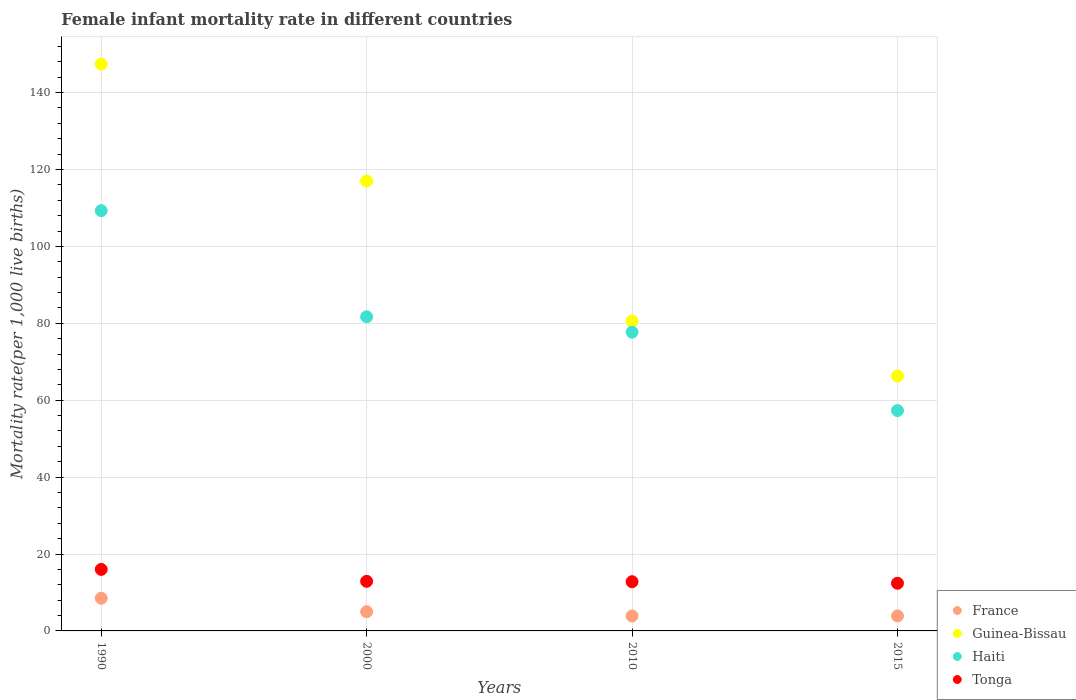How many different coloured dotlines are there?
Offer a terse response. 4. Across all years, what is the maximum female infant mortality rate in Haiti?
Keep it short and to the point. 109.3. Across all years, what is the minimum female infant mortality rate in Guinea-Bissau?
Your response must be concise. 66.3. In which year was the female infant mortality rate in Tonga maximum?
Ensure brevity in your answer.  1990. In which year was the female infant mortality rate in Guinea-Bissau minimum?
Provide a succinct answer. 2015. What is the total female infant mortality rate in Guinea-Bissau in the graph?
Your answer should be very brief. 411.3. What is the difference between the female infant mortality rate in Guinea-Bissau in 1990 and that in 2015?
Keep it short and to the point. 81.1. What is the difference between the female infant mortality rate in Tonga in 2015 and the female infant mortality rate in Haiti in 1990?
Make the answer very short. -96.9. What is the average female infant mortality rate in Tonga per year?
Ensure brevity in your answer.  13.53. In the year 2000, what is the difference between the female infant mortality rate in Guinea-Bissau and female infant mortality rate in France?
Offer a terse response. 112. What is the ratio of the female infant mortality rate in Guinea-Bissau in 2000 to that in 2015?
Give a very brief answer. 1.76. Is the female infant mortality rate in Haiti in 2010 less than that in 2015?
Your response must be concise. No. Is the difference between the female infant mortality rate in Guinea-Bissau in 1990 and 2010 greater than the difference between the female infant mortality rate in France in 1990 and 2010?
Your answer should be compact. Yes. What is the difference between the highest and the second highest female infant mortality rate in France?
Your answer should be very brief. 3.5. What is the difference between the highest and the lowest female infant mortality rate in Guinea-Bissau?
Ensure brevity in your answer.  81.1. In how many years, is the female infant mortality rate in Haiti greater than the average female infant mortality rate in Haiti taken over all years?
Give a very brief answer. 2. Is the sum of the female infant mortality rate in France in 2010 and 2015 greater than the maximum female infant mortality rate in Guinea-Bissau across all years?
Your response must be concise. No. Is it the case that in every year, the sum of the female infant mortality rate in Guinea-Bissau and female infant mortality rate in France  is greater than the sum of female infant mortality rate in Tonga and female infant mortality rate in Haiti?
Your answer should be very brief. Yes. Is it the case that in every year, the sum of the female infant mortality rate in Haiti and female infant mortality rate in Guinea-Bissau  is greater than the female infant mortality rate in Tonga?
Keep it short and to the point. Yes. How many dotlines are there?
Give a very brief answer. 4. How many years are there in the graph?
Provide a succinct answer. 4. Does the graph contain grids?
Your answer should be very brief. Yes. How many legend labels are there?
Offer a very short reply. 4. What is the title of the graph?
Your answer should be very brief. Female infant mortality rate in different countries. Does "Central African Republic" appear as one of the legend labels in the graph?
Provide a short and direct response. No. What is the label or title of the X-axis?
Provide a succinct answer. Years. What is the label or title of the Y-axis?
Ensure brevity in your answer.  Mortality rate(per 1,0 live births). What is the Mortality rate(per 1,000 live births) in Guinea-Bissau in 1990?
Your response must be concise. 147.4. What is the Mortality rate(per 1,000 live births) of Haiti in 1990?
Make the answer very short. 109.3. What is the Mortality rate(per 1,000 live births) in France in 2000?
Your answer should be very brief. 5. What is the Mortality rate(per 1,000 live births) of Guinea-Bissau in 2000?
Provide a short and direct response. 117. What is the Mortality rate(per 1,000 live births) in Haiti in 2000?
Provide a succinct answer. 81.7. What is the Mortality rate(per 1,000 live births) in Tonga in 2000?
Ensure brevity in your answer.  12.9. What is the Mortality rate(per 1,000 live births) of France in 2010?
Your response must be concise. 3.9. What is the Mortality rate(per 1,000 live births) in Guinea-Bissau in 2010?
Your response must be concise. 80.6. What is the Mortality rate(per 1,000 live births) in Haiti in 2010?
Offer a terse response. 77.7. What is the Mortality rate(per 1,000 live births) of Guinea-Bissau in 2015?
Provide a short and direct response. 66.3. What is the Mortality rate(per 1,000 live births) of Haiti in 2015?
Your response must be concise. 57.3. Across all years, what is the maximum Mortality rate(per 1,000 live births) of Guinea-Bissau?
Make the answer very short. 147.4. Across all years, what is the maximum Mortality rate(per 1,000 live births) in Haiti?
Offer a terse response. 109.3. Across all years, what is the minimum Mortality rate(per 1,000 live births) in Guinea-Bissau?
Offer a terse response. 66.3. Across all years, what is the minimum Mortality rate(per 1,000 live births) of Haiti?
Keep it short and to the point. 57.3. Across all years, what is the minimum Mortality rate(per 1,000 live births) of Tonga?
Your answer should be very brief. 12.4. What is the total Mortality rate(per 1,000 live births) in France in the graph?
Your answer should be very brief. 21.3. What is the total Mortality rate(per 1,000 live births) of Guinea-Bissau in the graph?
Ensure brevity in your answer.  411.3. What is the total Mortality rate(per 1,000 live births) in Haiti in the graph?
Your answer should be very brief. 326. What is the total Mortality rate(per 1,000 live births) of Tonga in the graph?
Your answer should be compact. 54.1. What is the difference between the Mortality rate(per 1,000 live births) of Guinea-Bissau in 1990 and that in 2000?
Offer a terse response. 30.4. What is the difference between the Mortality rate(per 1,000 live births) of Haiti in 1990 and that in 2000?
Ensure brevity in your answer.  27.6. What is the difference between the Mortality rate(per 1,000 live births) in Tonga in 1990 and that in 2000?
Make the answer very short. 3.1. What is the difference between the Mortality rate(per 1,000 live births) of Guinea-Bissau in 1990 and that in 2010?
Make the answer very short. 66.8. What is the difference between the Mortality rate(per 1,000 live births) in Haiti in 1990 and that in 2010?
Keep it short and to the point. 31.6. What is the difference between the Mortality rate(per 1,000 live births) in Tonga in 1990 and that in 2010?
Keep it short and to the point. 3.2. What is the difference between the Mortality rate(per 1,000 live births) in France in 1990 and that in 2015?
Your answer should be compact. 4.6. What is the difference between the Mortality rate(per 1,000 live births) of Guinea-Bissau in 1990 and that in 2015?
Offer a terse response. 81.1. What is the difference between the Mortality rate(per 1,000 live births) of Haiti in 1990 and that in 2015?
Provide a succinct answer. 52. What is the difference between the Mortality rate(per 1,000 live births) in Guinea-Bissau in 2000 and that in 2010?
Keep it short and to the point. 36.4. What is the difference between the Mortality rate(per 1,000 live births) in Tonga in 2000 and that in 2010?
Keep it short and to the point. 0.1. What is the difference between the Mortality rate(per 1,000 live births) in France in 2000 and that in 2015?
Make the answer very short. 1.1. What is the difference between the Mortality rate(per 1,000 live births) of Guinea-Bissau in 2000 and that in 2015?
Your response must be concise. 50.7. What is the difference between the Mortality rate(per 1,000 live births) in Haiti in 2000 and that in 2015?
Your answer should be very brief. 24.4. What is the difference between the Mortality rate(per 1,000 live births) in Guinea-Bissau in 2010 and that in 2015?
Provide a short and direct response. 14.3. What is the difference between the Mortality rate(per 1,000 live births) of Haiti in 2010 and that in 2015?
Your response must be concise. 20.4. What is the difference between the Mortality rate(per 1,000 live births) of France in 1990 and the Mortality rate(per 1,000 live births) of Guinea-Bissau in 2000?
Your response must be concise. -108.5. What is the difference between the Mortality rate(per 1,000 live births) of France in 1990 and the Mortality rate(per 1,000 live births) of Haiti in 2000?
Offer a terse response. -73.2. What is the difference between the Mortality rate(per 1,000 live births) of France in 1990 and the Mortality rate(per 1,000 live births) of Tonga in 2000?
Your response must be concise. -4.4. What is the difference between the Mortality rate(per 1,000 live births) in Guinea-Bissau in 1990 and the Mortality rate(per 1,000 live births) in Haiti in 2000?
Keep it short and to the point. 65.7. What is the difference between the Mortality rate(per 1,000 live births) in Guinea-Bissau in 1990 and the Mortality rate(per 1,000 live births) in Tonga in 2000?
Ensure brevity in your answer.  134.5. What is the difference between the Mortality rate(per 1,000 live births) in Haiti in 1990 and the Mortality rate(per 1,000 live births) in Tonga in 2000?
Your response must be concise. 96.4. What is the difference between the Mortality rate(per 1,000 live births) in France in 1990 and the Mortality rate(per 1,000 live births) in Guinea-Bissau in 2010?
Make the answer very short. -72.1. What is the difference between the Mortality rate(per 1,000 live births) of France in 1990 and the Mortality rate(per 1,000 live births) of Haiti in 2010?
Provide a short and direct response. -69.2. What is the difference between the Mortality rate(per 1,000 live births) in France in 1990 and the Mortality rate(per 1,000 live births) in Tonga in 2010?
Your answer should be very brief. -4.3. What is the difference between the Mortality rate(per 1,000 live births) of Guinea-Bissau in 1990 and the Mortality rate(per 1,000 live births) of Haiti in 2010?
Give a very brief answer. 69.7. What is the difference between the Mortality rate(per 1,000 live births) of Guinea-Bissau in 1990 and the Mortality rate(per 1,000 live births) of Tonga in 2010?
Your answer should be very brief. 134.6. What is the difference between the Mortality rate(per 1,000 live births) in Haiti in 1990 and the Mortality rate(per 1,000 live births) in Tonga in 2010?
Make the answer very short. 96.5. What is the difference between the Mortality rate(per 1,000 live births) of France in 1990 and the Mortality rate(per 1,000 live births) of Guinea-Bissau in 2015?
Ensure brevity in your answer.  -57.8. What is the difference between the Mortality rate(per 1,000 live births) in France in 1990 and the Mortality rate(per 1,000 live births) in Haiti in 2015?
Your response must be concise. -48.8. What is the difference between the Mortality rate(per 1,000 live births) in Guinea-Bissau in 1990 and the Mortality rate(per 1,000 live births) in Haiti in 2015?
Offer a very short reply. 90.1. What is the difference between the Mortality rate(per 1,000 live births) in Guinea-Bissau in 1990 and the Mortality rate(per 1,000 live births) in Tonga in 2015?
Your response must be concise. 135. What is the difference between the Mortality rate(per 1,000 live births) of Haiti in 1990 and the Mortality rate(per 1,000 live births) of Tonga in 2015?
Provide a succinct answer. 96.9. What is the difference between the Mortality rate(per 1,000 live births) in France in 2000 and the Mortality rate(per 1,000 live births) in Guinea-Bissau in 2010?
Provide a succinct answer. -75.6. What is the difference between the Mortality rate(per 1,000 live births) in France in 2000 and the Mortality rate(per 1,000 live births) in Haiti in 2010?
Offer a terse response. -72.7. What is the difference between the Mortality rate(per 1,000 live births) of Guinea-Bissau in 2000 and the Mortality rate(per 1,000 live births) of Haiti in 2010?
Your answer should be very brief. 39.3. What is the difference between the Mortality rate(per 1,000 live births) of Guinea-Bissau in 2000 and the Mortality rate(per 1,000 live births) of Tonga in 2010?
Offer a terse response. 104.2. What is the difference between the Mortality rate(per 1,000 live births) in Haiti in 2000 and the Mortality rate(per 1,000 live births) in Tonga in 2010?
Keep it short and to the point. 68.9. What is the difference between the Mortality rate(per 1,000 live births) in France in 2000 and the Mortality rate(per 1,000 live births) in Guinea-Bissau in 2015?
Offer a very short reply. -61.3. What is the difference between the Mortality rate(per 1,000 live births) in France in 2000 and the Mortality rate(per 1,000 live births) in Haiti in 2015?
Make the answer very short. -52.3. What is the difference between the Mortality rate(per 1,000 live births) of Guinea-Bissau in 2000 and the Mortality rate(per 1,000 live births) of Haiti in 2015?
Your response must be concise. 59.7. What is the difference between the Mortality rate(per 1,000 live births) in Guinea-Bissau in 2000 and the Mortality rate(per 1,000 live births) in Tonga in 2015?
Give a very brief answer. 104.6. What is the difference between the Mortality rate(per 1,000 live births) in Haiti in 2000 and the Mortality rate(per 1,000 live births) in Tonga in 2015?
Provide a short and direct response. 69.3. What is the difference between the Mortality rate(per 1,000 live births) of France in 2010 and the Mortality rate(per 1,000 live births) of Guinea-Bissau in 2015?
Ensure brevity in your answer.  -62.4. What is the difference between the Mortality rate(per 1,000 live births) of France in 2010 and the Mortality rate(per 1,000 live births) of Haiti in 2015?
Give a very brief answer. -53.4. What is the difference between the Mortality rate(per 1,000 live births) of Guinea-Bissau in 2010 and the Mortality rate(per 1,000 live births) of Haiti in 2015?
Your response must be concise. 23.3. What is the difference between the Mortality rate(per 1,000 live births) in Guinea-Bissau in 2010 and the Mortality rate(per 1,000 live births) in Tonga in 2015?
Offer a very short reply. 68.2. What is the difference between the Mortality rate(per 1,000 live births) of Haiti in 2010 and the Mortality rate(per 1,000 live births) of Tonga in 2015?
Make the answer very short. 65.3. What is the average Mortality rate(per 1,000 live births) of France per year?
Your answer should be very brief. 5.33. What is the average Mortality rate(per 1,000 live births) in Guinea-Bissau per year?
Provide a succinct answer. 102.83. What is the average Mortality rate(per 1,000 live births) in Haiti per year?
Your answer should be compact. 81.5. What is the average Mortality rate(per 1,000 live births) in Tonga per year?
Your answer should be very brief. 13.53. In the year 1990, what is the difference between the Mortality rate(per 1,000 live births) in France and Mortality rate(per 1,000 live births) in Guinea-Bissau?
Your answer should be compact. -138.9. In the year 1990, what is the difference between the Mortality rate(per 1,000 live births) in France and Mortality rate(per 1,000 live births) in Haiti?
Offer a very short reply. -100.8. In the year 1990, what is the difference between the Mortality rate(per 1,000 live births) in Guinea-Bissau and Mortality rate(per 1,000 live births) in Haiti?
Provide a short and direct response. 38.1. In the year 1990, what is the difference between the Mortality rate(per 1,000 live births) of Guinea-Bissau and Mortality rate(per 1,000 live births) of Tonga?
Keep it short and to the point. 131.4. In the year 1990, what is the difference between the Mortality rate(per 1,000 live births) of Haiti and Mortality rate(per 1,000 live births) of Tonga?
Ensure brevity in your answer.  93.3. In the year 2000, what is the difference between the Mortality rate(per 1,000 live births) in France and Mortality rate(per 1,000 live births) in Guinea-Bissau?
Provide a short and direct response. -112. In the year 2000, what is the difference between the Mortality rate(per 1,000 live births) in France and Mortality rate(per 1,000 live births) in Haiti?
Keep it short and to the point. -76.7. In the year 2000, what is the difference between the Mortality rate(per 1,000 live births) in France and Mortality rate(per 1,000 live births) in Tonga?
Give a very brief answer. -7.9. In the year 2000, what is the difference between the Mortality rate(per 1,000 live births) of Guinea-Bissau and Mortality rate(per 1,000 live births) of Haiti?
Provide a short and direct response. 35.3. In the year 2000, what is the difference between the Mortality rate(per 1,000 live births) of Guinea-Bissau and Mortality rate(per 1,000 live births) of Tonga?
Provide a short and direct response. 104.1. In the year 2000, what is the difference between the Mortality rate(per 1,000 live births) in Haiti and Mortality rate(per 1,000 live births) in Tonga?
Offer a very short reply. 68.8. In the year 2010, what is the difference between the Mortality rate(per 1,000 live births) of France and Mortality rate(per 1,000 live births) of Guinea-Bissau?
Your answer should be very brief. -76.7. In the year 2010, what is the difference between the Mortality rate(per 1,000 live births) in France and Mortality rate(per 1,000 live births) in Haiti?
Your answer should be very brief. -73.8. In the year 2010, what is the difference between the Mortality rate(per 1,000 live births) of Guinea-Bissau and Mortality rate(per 1,000 live births) of Tonga?
Your answer should be compact. 67.8. In the year 2010, what is the difference between the Mortality rate(per 1,000 live births) of Haiti and Mortality rate(per 1,000 live births) of Tonga?
Offer a very short reply. 64.9. In the year 2015, what is the difference between the Mortality rate(per 1,000 live births) in France and Mortality rate(per 1,000 live births) in Guinea-Bissau?
Offer a very short reply. -62.4. In the year 2015, what is the difference between the Mortality rate(per 1,000 live births) of France and Mortality rate(per 1,000 live births) of Haiti?
Offer a terse response. -53.4. In the year 2015, what is the difference between the Mortality rate(per 1,000 live births) of Guinea-Bissau and Mortality rate(per 1,000 live births) of Tonga?
Ensure brevity in your answer.  53.9. In the year 2015, what is the difference between the Mortality rate(per 1,000 live births) of Haiti and Mortality rate(per 1,000 live births) of Tonga?
Your response must be concise. 44.9. What is the ratio of the Mortality rate(per 1,000 live births) in France in 1990 to that in 2000?
Your answer should be very brief. 1.7. What is the ratio of the Mortality rate(per 1,000 live births) in Guinea-Bissau in 1990 to that in 2000?
Give a very brief answer. 1.26. What is the ratio of the Mortality rate(per 1,000 live births) in Haiti in 1990 to that in 2000?
Provide a succinct answer. 1.34. What is the ratio of the Mortality rate(per 1,000 live births) of Tonga in 1990 to that in 2000?
Your answer should be compact. 1.24. What is the ratio of the Mortality rate(per 1,000 live births) of France in 1990 to that in 2010?
Your answer should be compact. 2.18. What is the ratio of the Mortality rate(per 1,000 live births) in Guinea-Bissau in 1990 to that in 2010?
Give a very brief answer. 1.83. What is the ratio of the Mortality rate(per 1,000 live births) of Haiti in 1990 to that in 2010?
Keep it short and to the point. 1.41. What is the ratio of the Mortality rate(per 1,000 live births) of France in 1990 to that in 2015?
Keep it short and to the point. 2.18. What is the ratio of the Mortality rate(per 1,000 live births) in Guinea-Bissau in 1990 to that in 2015?
Provide a succinct answer. 2.22. What is the ratio of the Mortality rate(per 1,000 live births) of Haiti in 1990 to that in 2015?
Your response must be concise. 1.91. What is the ratio of the Mortality rate(per 1,000 live births) in Tonga in 1990 to that in 2015?
Provide a succinct answer. 1.29. What is the ratio of the Mortality rate(per 1,000 live births) in France in 2000 to that in 2010?
Your answer should be very brief. 1.28. What is the ratio of the Mortality rate(per 1,000 live births) of Guinea-Bissau in 2000 to that in 2010?
Provide a short and direct response. 1.45. What is the ratio of the Mortality rate(per 1,000 live births) of Haiti in 2000 to that in 2010?
Your answer should be compact. 1.05. What is the ratio of the Mortality rate(per 1,000 live births) in Tonga in 2000 to that in 2010?
Give a very brief answer. 1.01. What is the ratio of the Mortality rate(per 1,000 live births) of France in 2000 to that in 2015?
Keep it short and to the point. 1.28. What is the ratio of the Mortality rate(per 1,000 live births) of Guinea-Bissau in 2000 to that in 2015?
Ensure brevity in your answer.  1.76. What is the ratio of the Mortality rate(per 1,000 live births) in Haiti in 2000 to that in 2015?
Your answer should be compact. 1.43. What is the ratio of the Mortality rate(per 1,000 live births) of Tonga in 2000 to that in 2015?
Keep it short and to the point. 1.04. What is the ratio of the Mortality rate(per 1,000 live births) in France in 2010 to that in 2015?
Give a very brief answer. 1. What is the ratio of the Mortality rate(per 1,000 live births) in Guinea-Bissau in 2010 to that in 2015?
Provide a short and direct response. 1.22. What is the ratio of the Mortality rate(per 1,000 live births) of Haiti in 2010 to that in 2015?
Ensure brevity in your answer.  1.36. What is the ratio of the Mortality rate(per 1,000 live births) of Tonga in 2010 to that in 2015?
Give a very brief answer. 1.03. What is the difference between the highest and the second highest Mortality rate(per 1,000 live births) in Guinea-Bissau?
Offer a very short reply. 30.4. What is the difference between the highest and the second highest Mortality rate(per 1,000 live births) of Haiti?
Offer a terse response. 27.6. What is the difference between the highest and the lowest Mortality rate(per 1,000 live births) of Guinea-Bissau?
Your answer should be very brief. 81.1. What is the difference between the highest and the lowest Mortality rate(per 1,000 live births) of Tonga?
Ensure brevity in your answer.  3.6. 